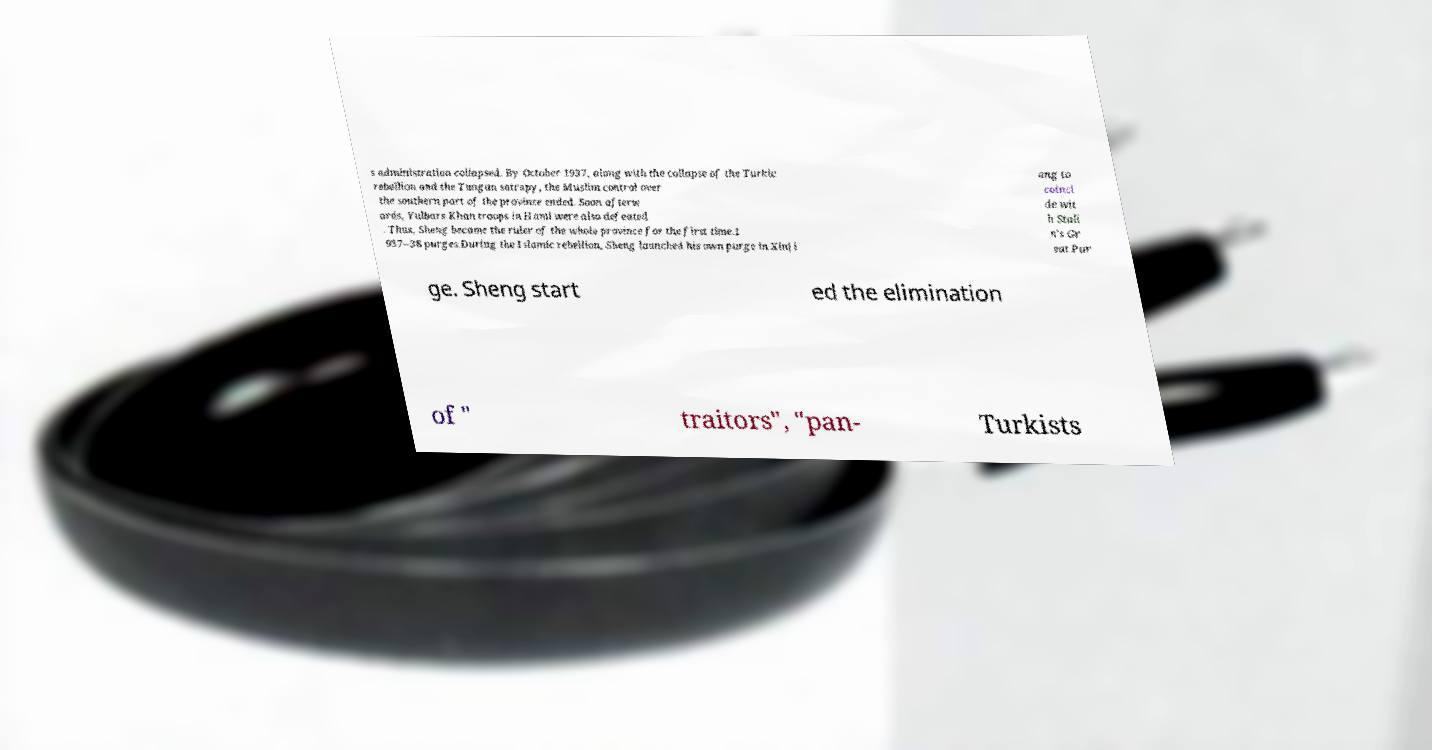Can you accurately transcribe the text from the provided image for me? s administration collapsed. By October 1937, along with the collapse of the Turkic rebellion and the Tungan satrapy, the Muslim control over the southern part of the province ended. Soon afterw ards, Yulbars Khan troops in Hami were also defeated . Thus, Sheng became the ruler of the whole province for the first time.1 937–38 purges.During the Islamic rebellion, Sheng launched his own purge in Xinji ang to coinci de wit h Stali n's Gr eat Pur ge. Sheng start ed the elimination of " traitors", "pan- Turkists 